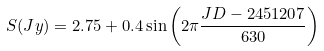Convert formula to latex. <formula><loc_0><loc_0><loc_500><loc_500>S ( J y ) = 2 . 7 5 + 0 . 4 \sin \left ( 2 \pi \frac { J D - 2 4 5 1 2 0 7 } { 6 3 0 } \right )</formula> 